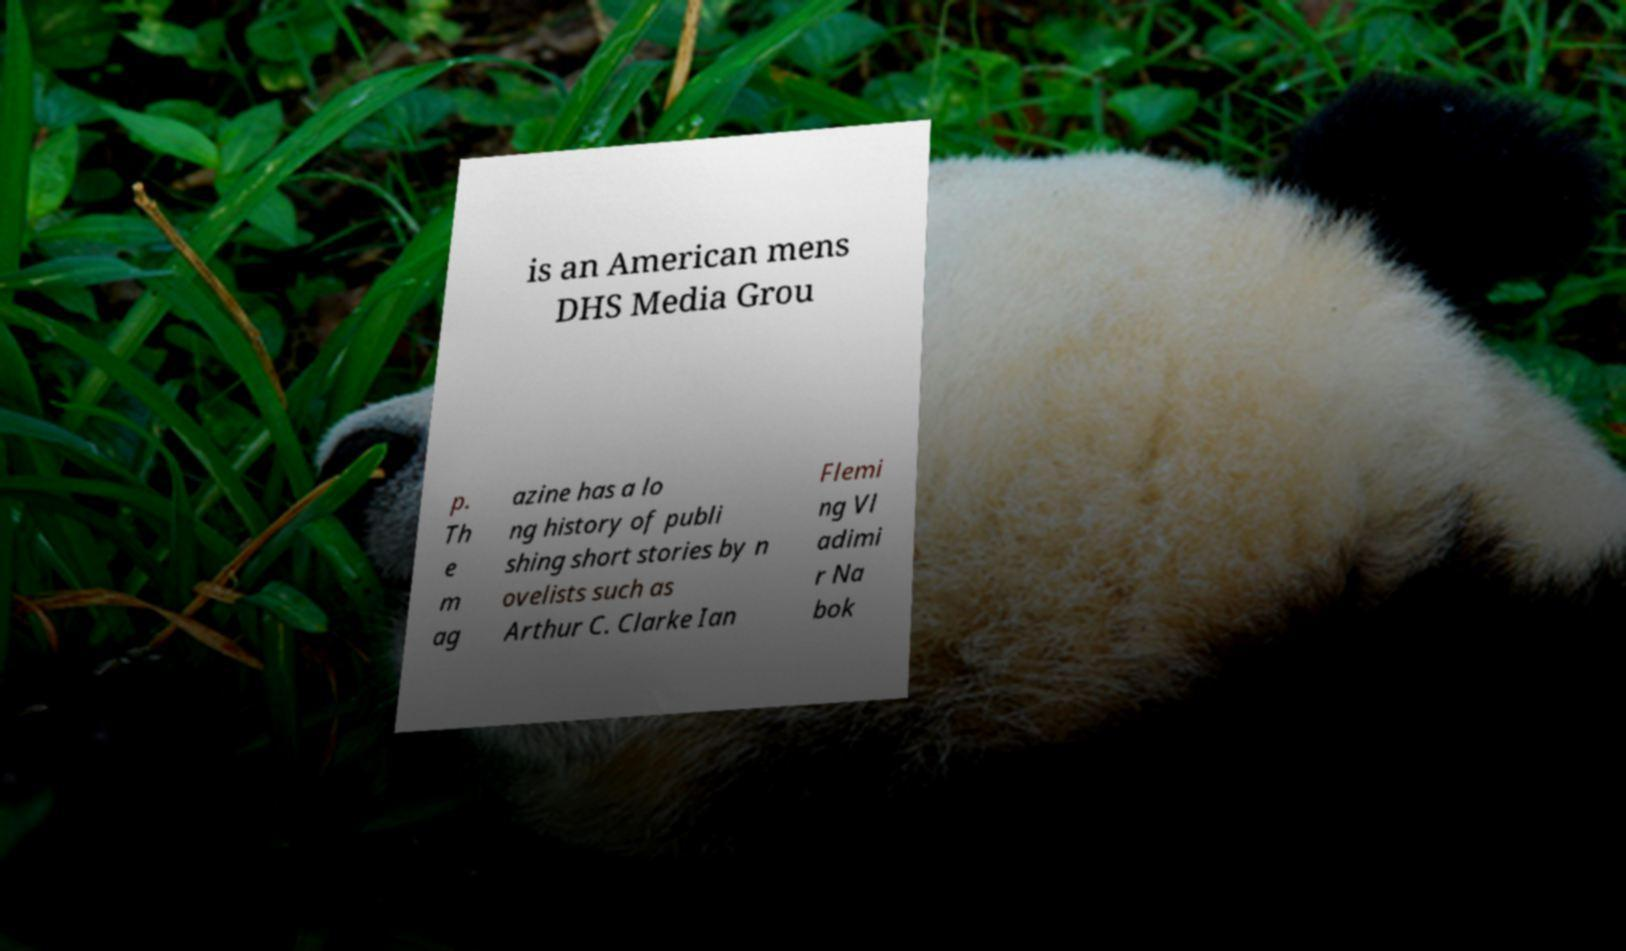I need the written content from this picture converted into text. Can you do that? is an American mens DHS Media Grou p. Th e m ag azine has a lo ng history of publi shing short stories by n ovelists such as Arthur C. Clarke Ian Flemi ng Vl adimi r Na bok 